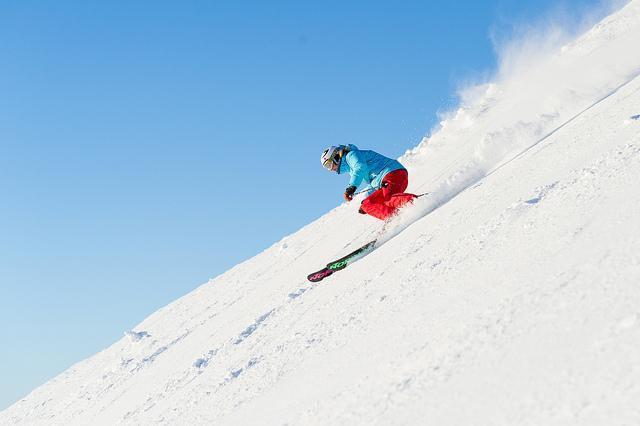How many dogs are pictured?
Give a very brief answer. 0. 